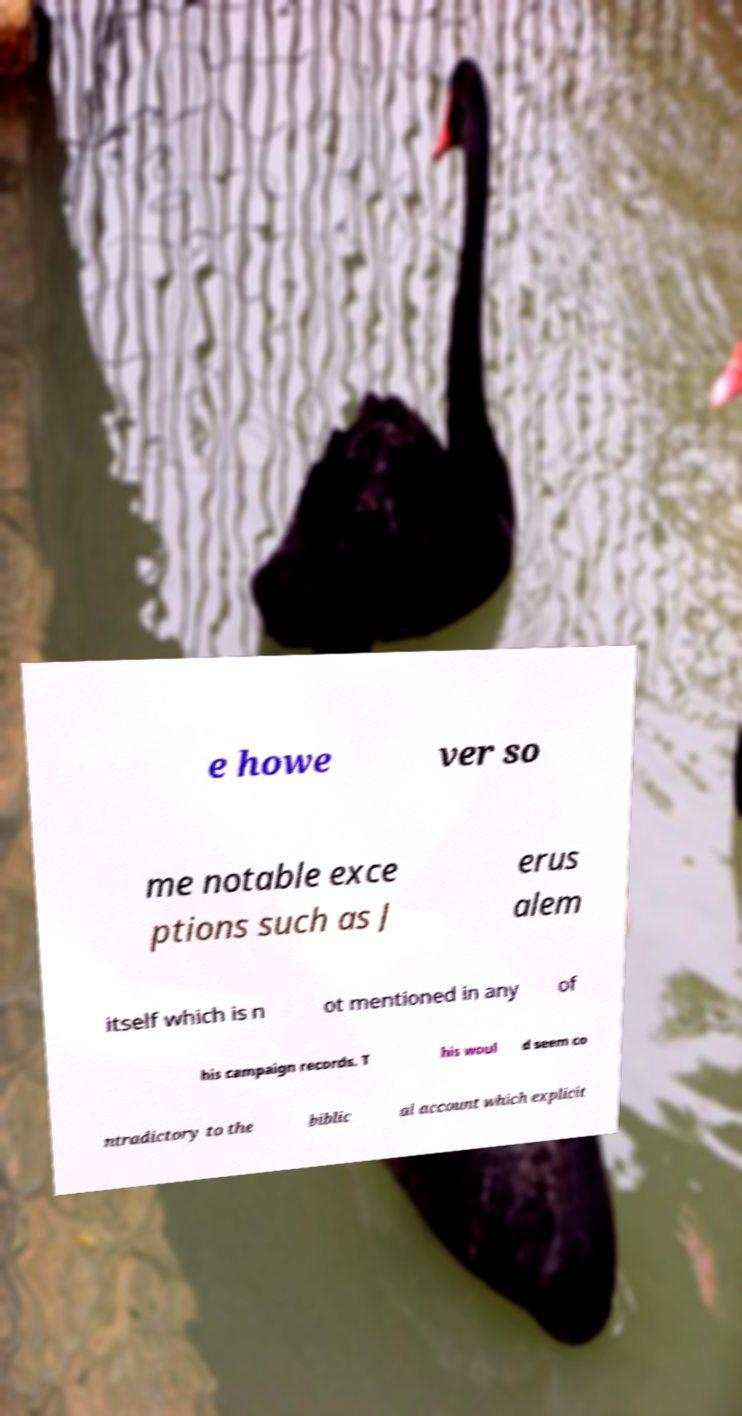I need the written content from this picture converted into text. Can you do that? e howe ver so me notable exce ptions such as J erus alem itself which is n ot mentioned in any of his campaign records. T his woul d seem co ntradictory to the biblic al account which explicit 